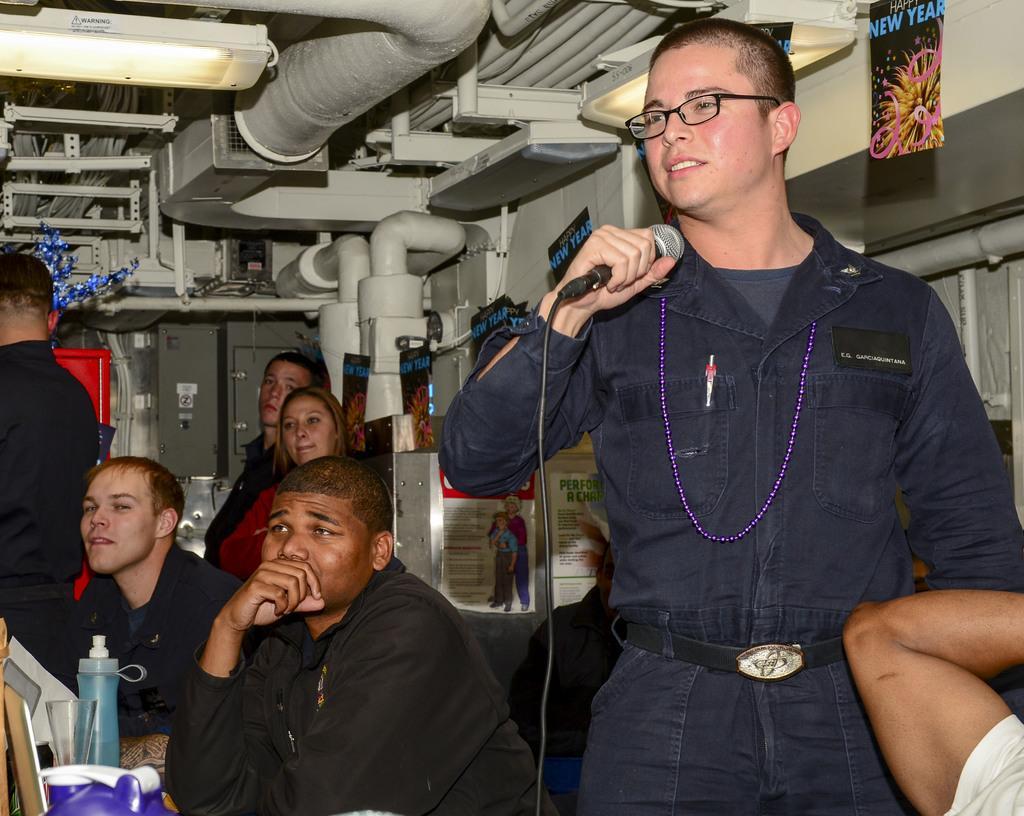Could you give a brief overview of what you see in this image? In this picture we can see man holding mic in his hand and talking and beside to him some persons are standing and some are sitting and in front of them there is bottle, glass, cloth and in background we can see pipes. 